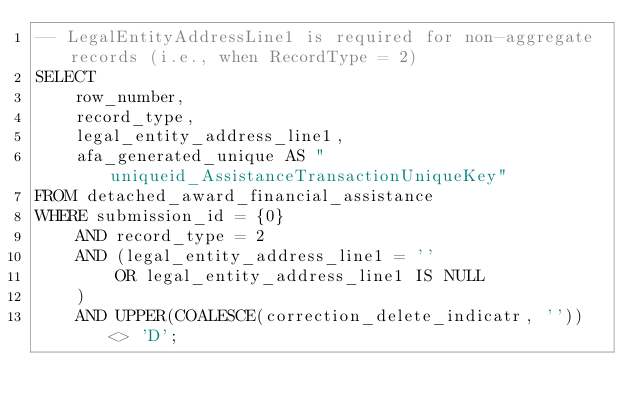Convert code to text. <code><loc_0><loc_0><loc_500><loc_500><_SQL_>-- LegalEntityAddressLine1 is required for non-aggregate records (i.e., when RecordType = 2)
SELECT
    row_number,
    record_type,
    legal_entity_address_line1,
    afa_generated_unique AS "uniqueid_AssistanceTransactionUniqueKey"
FROM detached_award_financial_assistance
WHERE submission_id = {0}
    AND record_type = 2
    AND (legal_entity_address_line1 = ''
        OR legal_entity_address_line1 IS NULL
    )
    AND UPPER(COALESCE(correction_delete_indicatr, '')) <> 'D';
</code> 